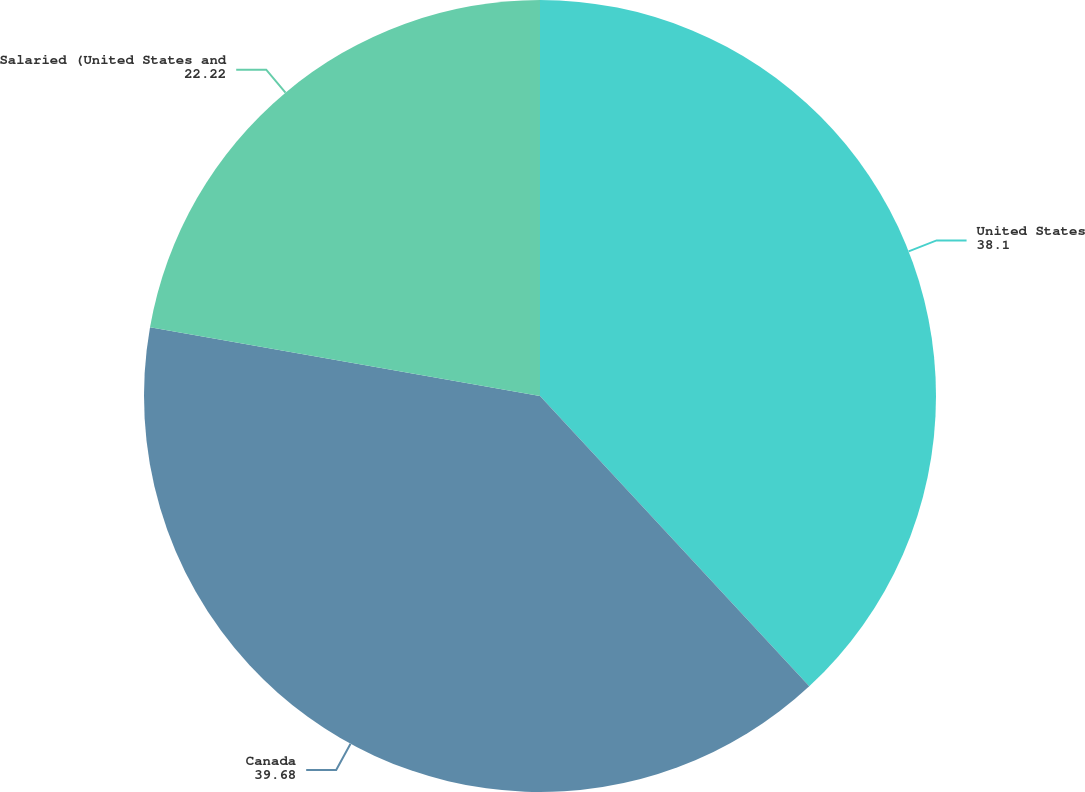<chart> <loc_0><loc_0><loc_500><loc_500><pie_chart><fcel>United States<fcel>Canada<fcel>Salaried (United States and<nl><fcel>38.1%<fcel>39.68%<fcel>22.22%<nl></chart> 